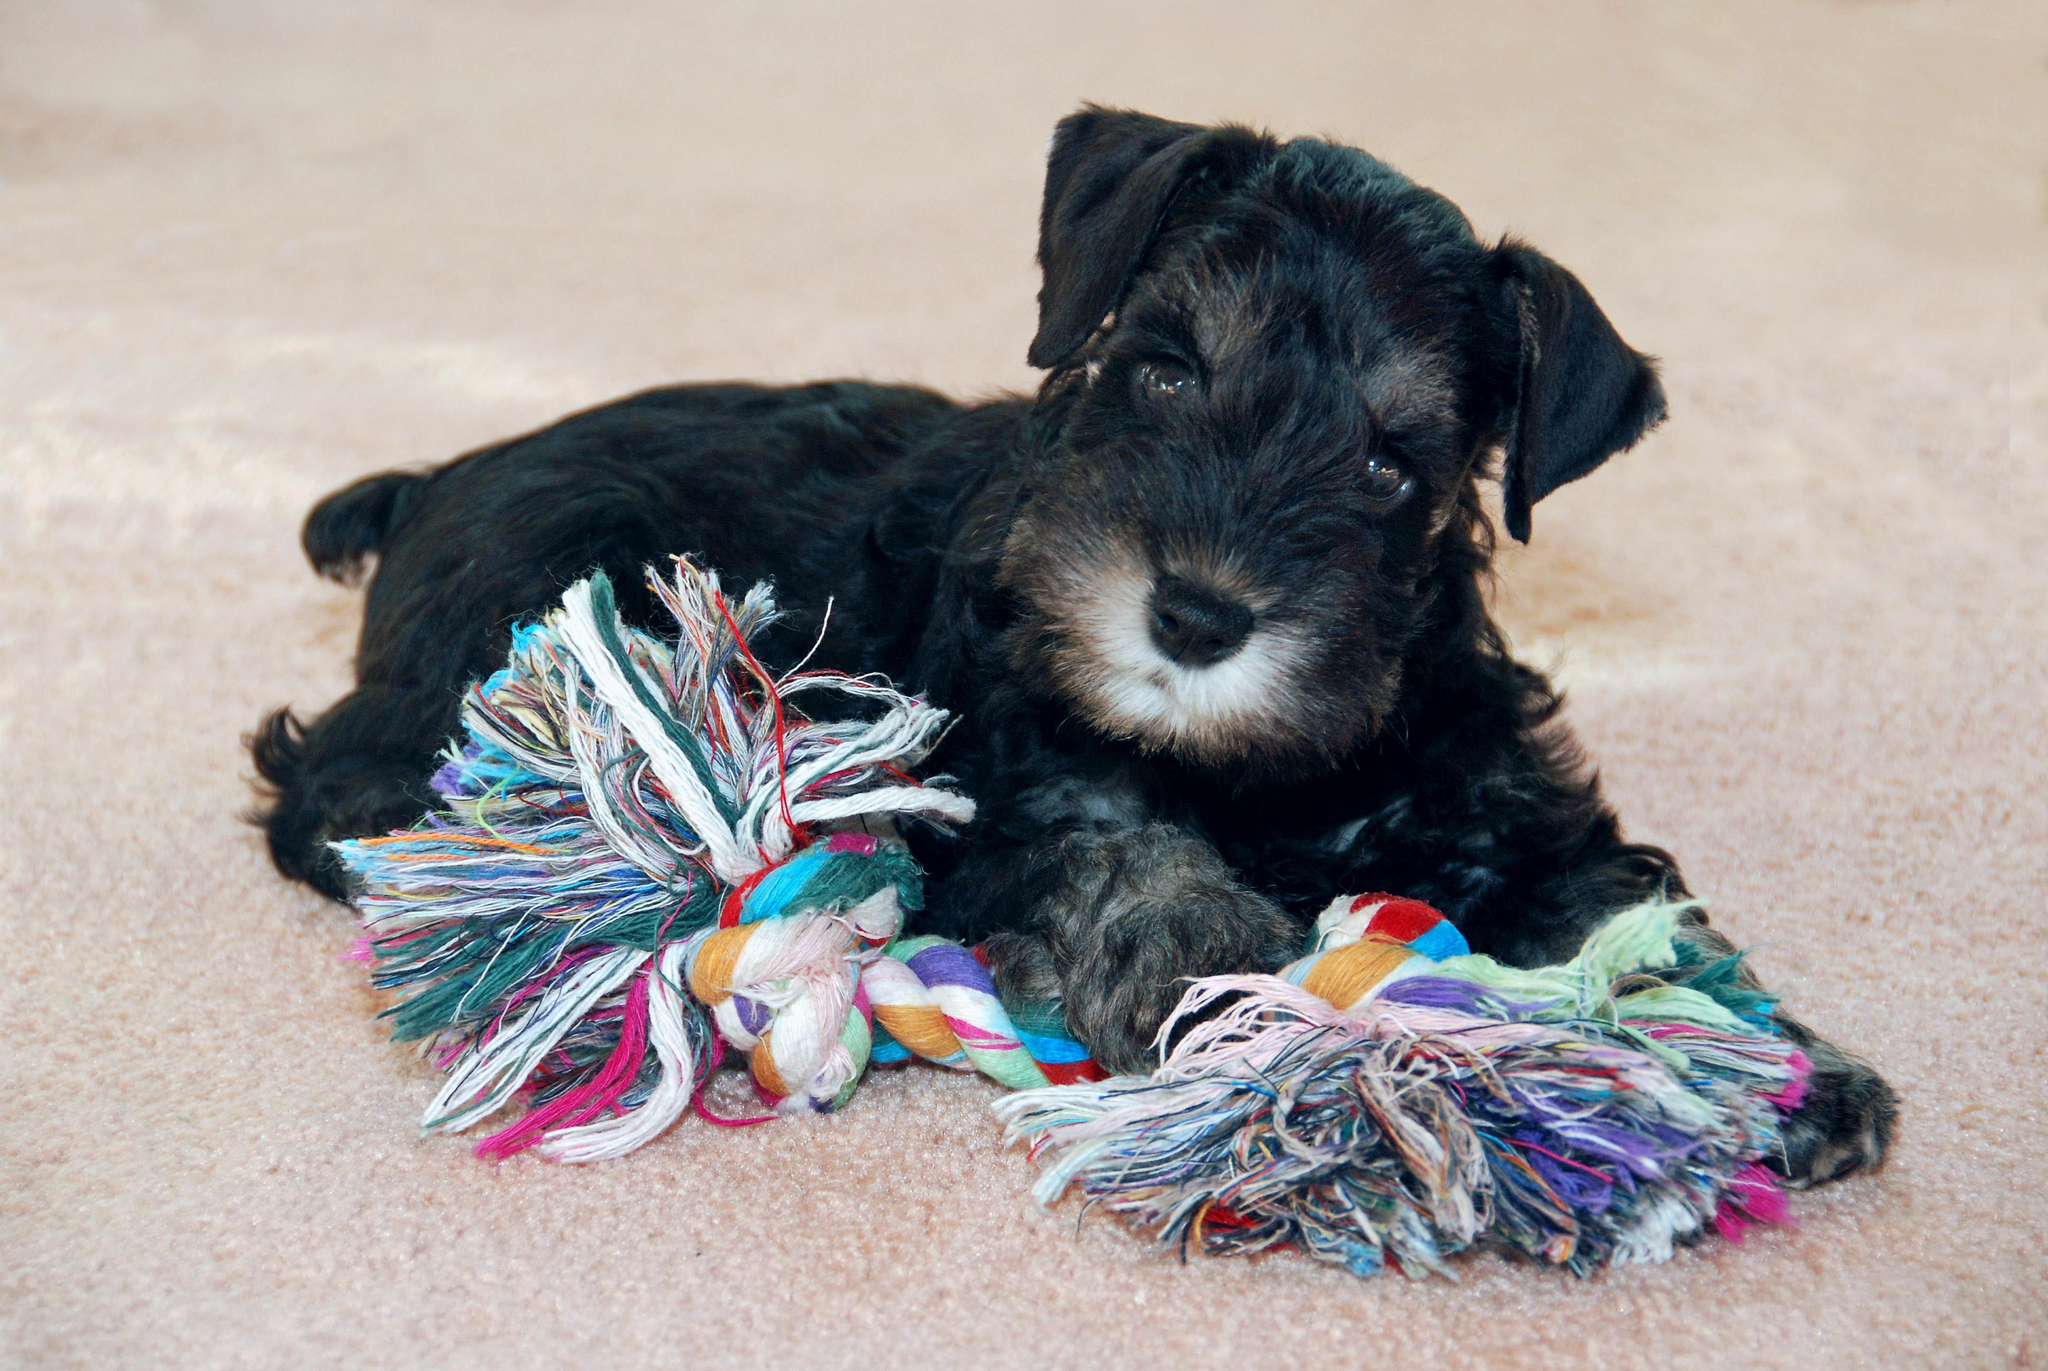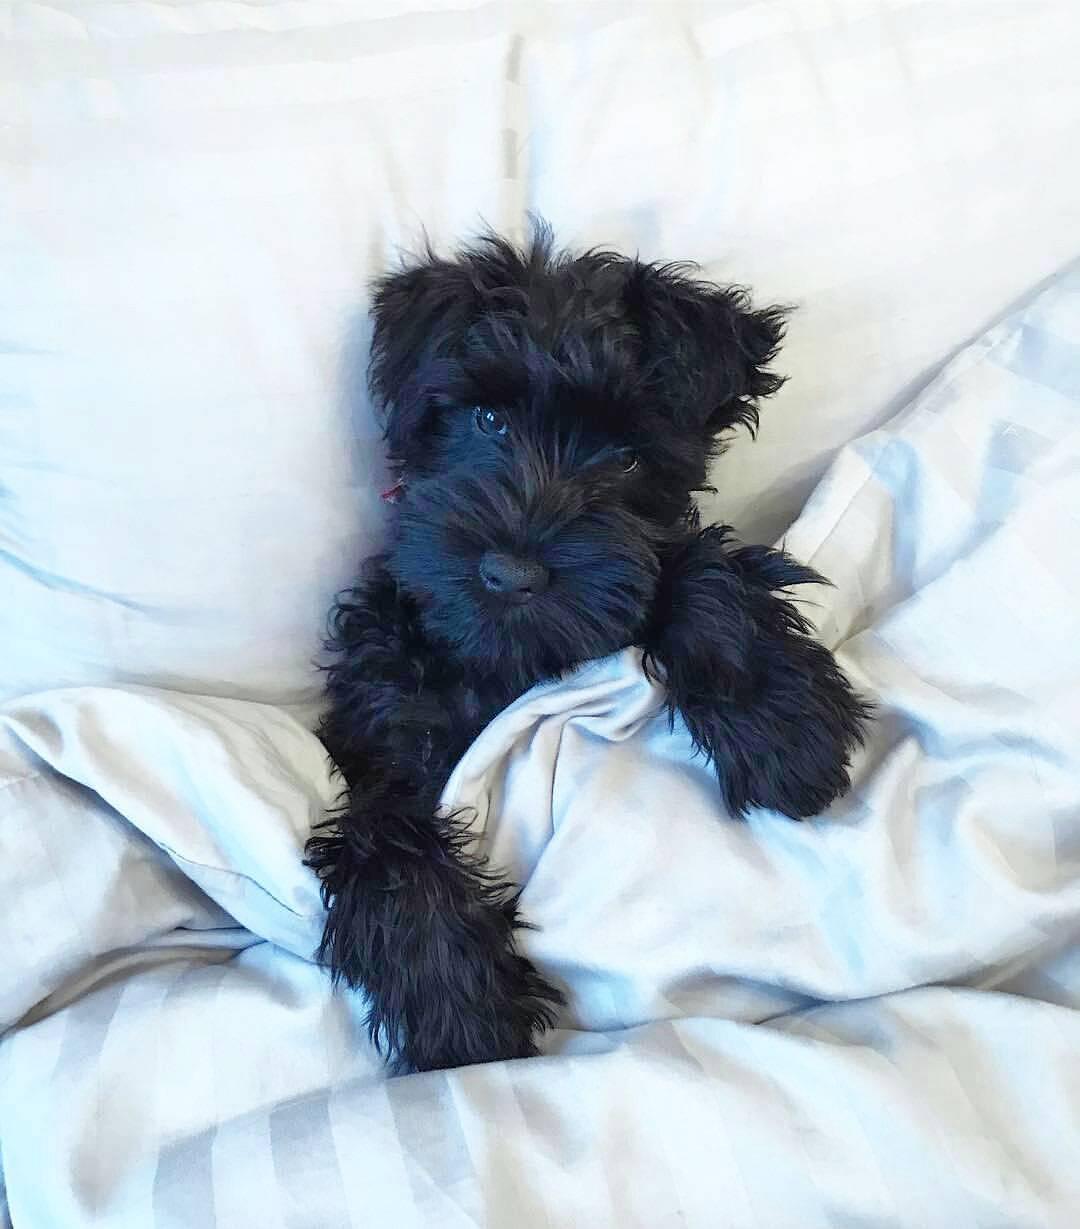The first image is the image on the left, the second image is the image on the right. For the images shown, is this caption "An image shows a puppy with paws on something with stringy yarn-like fibers." true? Answer yes or no. Yes. 